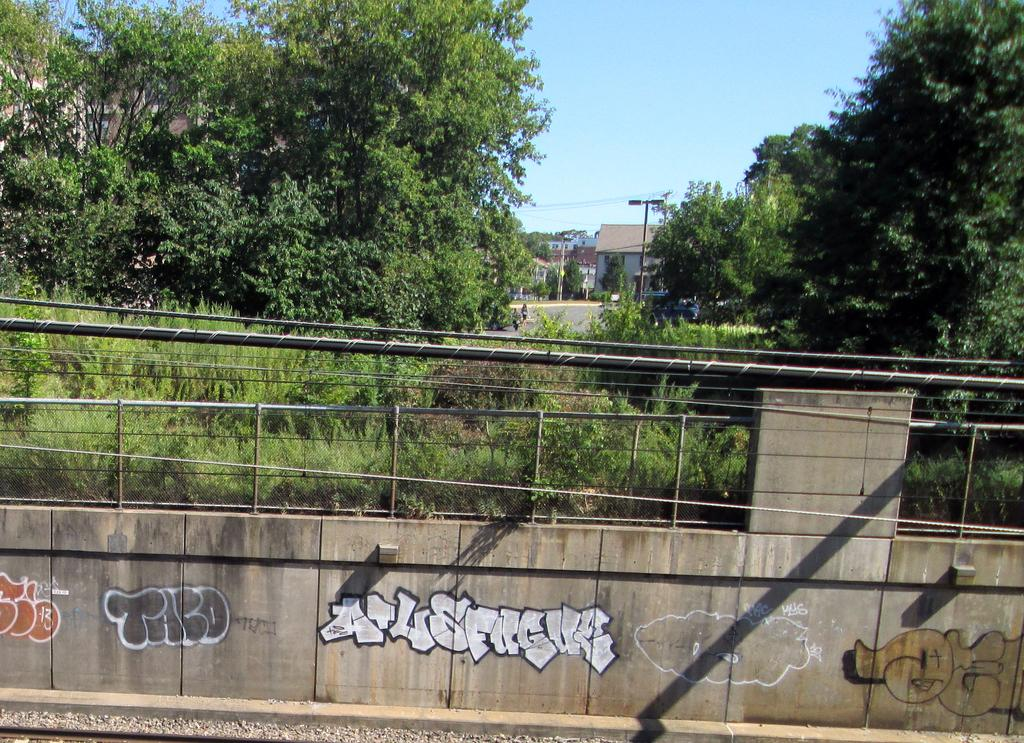What type of barrier can be seen in the image? There is a fence in the image. How is the fence connected to another structure? The fence is attached to a wall. What is located in front of the wall? There are trees and a road in front of the wall. What other structure is visible in front of the wall? There is a building in front of the wall. What can be seen at the top of the image? The sky is visible at the top of the image. How does the yak feel about the fence in the image? There is no yak present in the image, so it is not possible to determine how a yak might feel about the fence. 